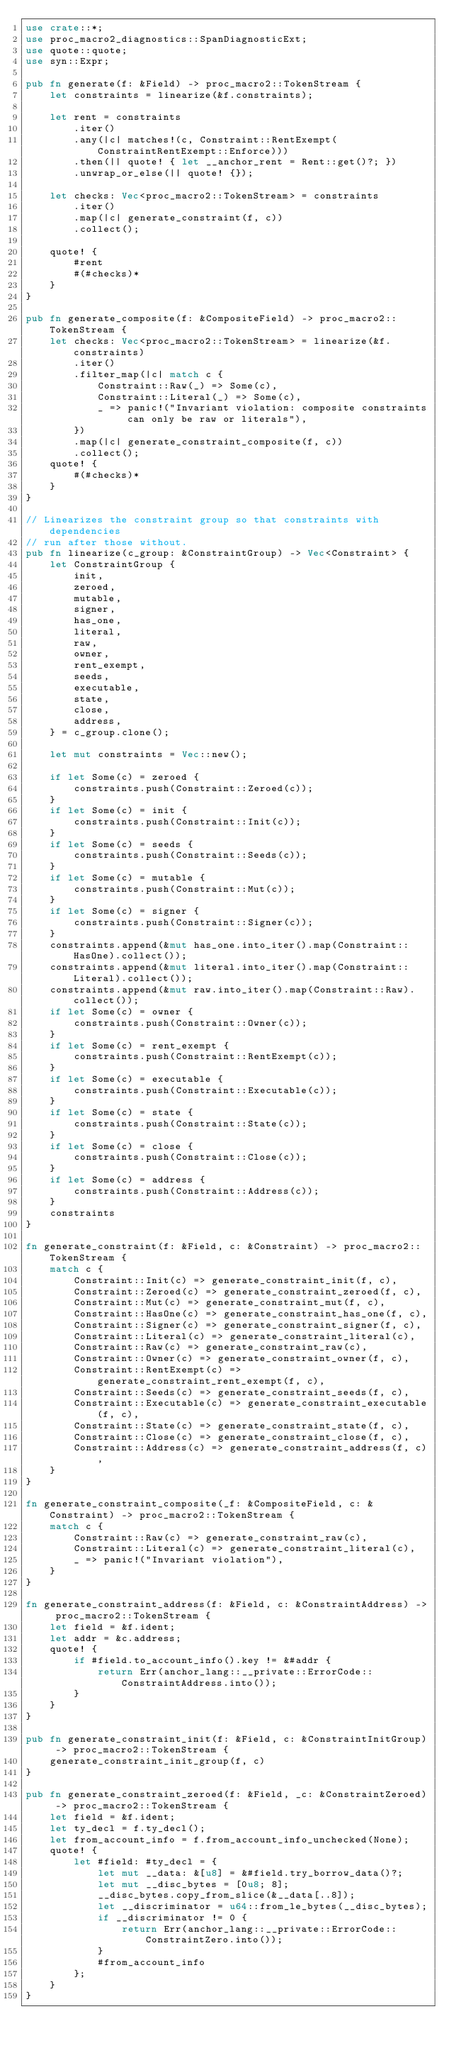Convert code to text. <code><loc_0><loc_0><loc_500><loc_500><_Rust_>use crate::*;
use proc_macro2_diagnostics::SpanDiagnosticExt;
use quote::quote;
use syn::Expr;

pub fn generate(f: &Field) -> proc_macro2::TokenStream {
    let constraints = linearize(&f.constraints);

    let rent = constraints
        .iter()
        .any(|c| matches!(c, Constraint::RentExempt(ConstraintRentExempt::Enforce)))
        .then(|| quote! { let __anchor_rent = Rent::get()?; })
        .unwrap_or_else(|| quote! {});

    let checks: Vec<proc_macro2::TokenStream> = constraints
        .iter()
        .map(|c| generate_constraint(f, c))
        .collect();

    quote! {
        #rent
        #(#checks)*
    }
}

pub fn generate_composite(f: &CompositeField) -> proc_macro2::TokenStream {
    let checks: Vec<proc_macro2::TokenStream> = linearize(&f.constraints)
        .iter()
        .filter_map(|c| match c {
            Constraint::Raw(_) => Some(c),
            Constraint::Literal(_) => Some(c),
            _ => panic!("Invariant violation: composite constraints can only be raw or literals"),
        })
        .map(|c| generate_constraint_composite(f, c))
        .collect();
    quote! {
        #(#checks)*
    }
}

// Linearizes the constraint group so that constraints with dependencies
// run after those without.
pub fn linearize(c_group: &ConstraintGroup) -> Vec<Constraint> {
    let ConstraintGroup {
        init,
        zeroed,
        mutable,
        signer,
        has_one,
        literal,
        raw,
        owner,
        rent_exempt,
        seeds,
        executable,
        state,
        close,
        address,
    } = c_group.clone();

    let mut constraints = Vec::new();

    if let Some(c) = zeroed {
        constraints.push(Constraint::Zeroed(c));
    }
    if let Some(c) = init {
        constraints.push(Constraint::Init(c));
    }
    if let Some(c) = seeds {
        constraints.push(Constraint::Seeds(c));
    }
    if let Some(c) = mutable {
        constraints.push(Constraint::Mut(c));
    }
    if let Some(c) = signer {
        constraints.push(Constraint::Signer(c));
    }
    constraints.append(&mut has_one.into_iter().map(Constraint::HasOne).collect());
    constraints.append(&mut literal.into_iter().map(Constraint::Literal).collect());
    constraints.append(&mut raw.into_iter().map(Constraint::Raw).collect());
    if let Some(c) = owner {
        constraints.push(Constraint::Owner(c));
    }
    if let Some(c) = rent_exempt {
        constraints.push(Constraint::RentExempt(c));
    }
    if let Some(c) = executable {
        constraints.push(Constraint::Executable(c));
    }
    if let Some(c) = state {
        constraints.push(Constraint::State(c));
    }
    if let Some(c) = close {
        constraints.push(Constraint::Close(c));
    }
    if let Some(c) = address {
        constraints.push(Constraint::Address(c));
    }
    constraints
}

fn generate_constraint(f: &Field, c: &Constraint) -> proc_macro2::TokenStream {
    match c {
        Constraint::Init(c) => generate_constraint_init(f, c),
        Constraint::Zeroed(c) => generate_constraint_zeroed(f, c),
        Constraint::Mut(c) => generate_constraint_mut(f, c),
        Constraint::HasOne(c) => generate_constraint_has_one(f, c),
        Constraint::Signer(c) => generate_constraint_signer(f, c),
        Constraint::Literal(c) => generate_constraint_literal(c),
        Constraint::Raw(c) => generate_constraint_raw(c),
        Constraint::Owner(c) => generate_constraint_owner(f, c),
        Constraint::RentExempt(c) => generate_constraint_rent_exempt(f, c),
        Constraint::Seeds(c) => generate_constraint_seeds(f, c),
        Constraint::Executable(c) => generate_constraint_executable(f, c),
        Constraint::State(c) => generate_constraint_state(f, c),
        Constraint::Close(c) => generate_constraint_close(f, c),
        Constraint::Address(c) => generate_constraint_address(f, c),
    }
}

fn generate_constraint_composite(_f: &CompositeField, c: &Constraint) -> proc_macro2::TokenStream {
    match c {
        Constraint::Raw(c) => generate_constraint_raw(c),
        Constraint::Literal(c) => generate_constraint_literal(c),
        _ => panic!("Invariant violation"),
    }
}

fn generate_constraint_address(f: &Field, c: &ConstraintAddress) -> proc_macro2::TokenStream {
    let field = &f.ident;
    let addr = &c.address;
    quote! {
        if #field.to_account_info().key != &#addr {
            return Err(anchor_lang::__private::ErrorCode::ConstraintAddress.into());
        }
    }
}

pub fn generate_constraint_init(f: &Field, c: &ConstraintInitGroup) -> proc_macro2::TokenStream {
    generate_constraint_init_group(f, c)
}

pub fn generate_constraint_zeroed(f: &Field, _c: &ConstraintZeroed) -> proc_macro2::TokenStream {
    let field = &f.ident;
    let ty_decl = f.ty_decl();
    let from_account_info = f.from_account_info_unchecked(None);
    quote! {
        let #field: #ty_decl = {
            let mut __data: &[u8] = &#field.try_borrow_data()?;
            let mut __disc_bytes = [0u8; 8];
            __disc_bytes.copy_from_slice(&__data[..8]);
            let __discriminator = u64::from_le_bytes(__disc_bytes);
            if __discriminator != 0 {
                return Err(anchor_lang::__private::ErrorCode::ConstraintZero.into());
            }
            #from_account_info
        };
    }
}
</code> 